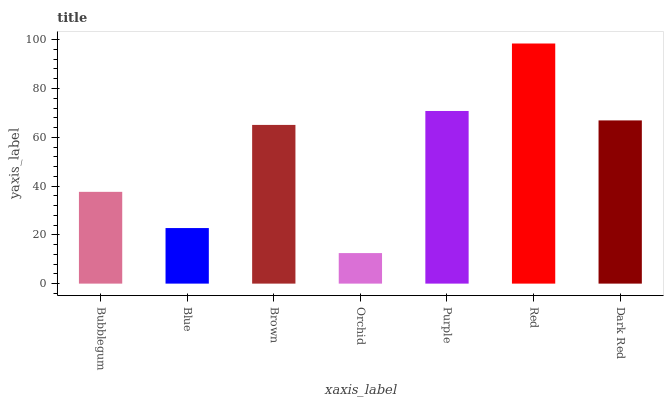Is Orchid the minimum?
Answer yes or no. Yes. Is Red the maximum?
Answer yes or no. Yes. Is Blue the minimum?
Answer yes or no. No. Is Blue the maximum?
Answer yes or no. No. Is Bubblegum greater than Blue?
Answer yes or no. Yes. Is Blue less than Bubblegum?
Answer yes or no. Yes. Is Blue greater than Bubblegum?
Answer yes or no. No. Is Bubblegum less than Blue?
Answer yes or no. No. Is Brown the high median?
Answer yes or no. Yes. Is Brown the low median?
Answer yes or no. Yes. Is Red the high median?
Answer yes or no. No. Is Bubblegum the low median?
Answer yes or no. No. 